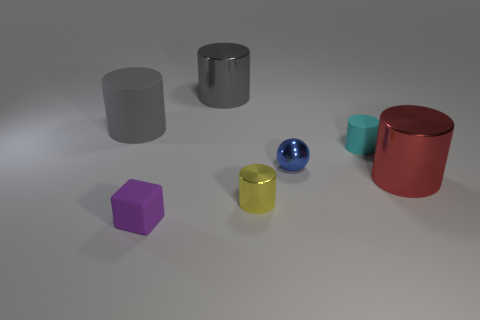Subtract 2 cylinders. How many cylinders are left? 3 Subtract all yellow cylinders. How many cylinders are left? 4 Subtract all red cylinders. How many cylinders are left? 4 Subtract all brown cylinders. Subtract all brown blocks. How many cylinders are left? 5 Add 1 big yellow cylinders. How many objects exist? 8 Subtract all balls. How many objects are left? 6 Add 1 tiny rubber cubes. How many tiny rubber cubes are left? 2 Add 6 red metallic cylinders. How many red metallic cylinders exist? 7 Subtract 0 purple balls. How many objects are left? 7 Subtract all small brown spheres. Subtract all yellow shiny cylinders. How many objects are left? 6 